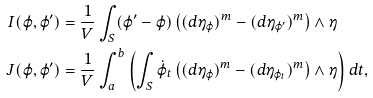<formula> <loc_0><loc_0><loc_500><loc_500>I ( \varphi , \varphi ^ { \prime } ) & = \frac { 1 } { V } \int _ { S } ( \varphi ^ { \prime } - \varphi ) \left ( ( d \eta _ { \varphi } ) ^ { m } - ( d \eta _ { \varphi ^ { \prime } } ) ^ { m } \right ) \wedge \eta \\ J ( \varphi , \varphi ^ { \prime } ) & = \frac { 1 } { V } \int _ { a } ^ { b } \left ( \int _ { S } \dot { \varphi } _ { t } \left ( ( d \eta _ { \varphi } ) ^ { m } - ( d \eta _ { \varphi _ { t } } ) ^ { m } \right ) \wedge \eta \right ) d t ,</formula> 